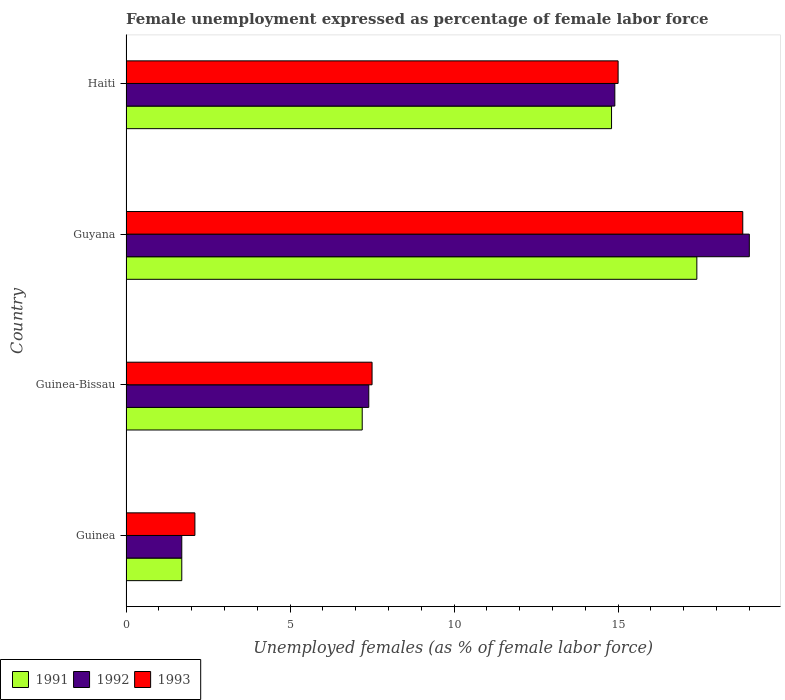How many groups of bars are there?
Offer a very short reply. 4. Are the number of bars per tick equal to the number of legend labels?
Your answer should be compact. Yes. What is the label of the 4th group of bars from the top?
Keep it short and to the point. Guinea. In how many cases, is the number of bars for a given country not equal to the number of legend labels?
Offer a very short reply. 0. What is the unemployment in females in in 1991 in Haiti?
Make the answer very short. 14.8. Across all countries, what is the maximum unemployment in females in in 1993?
Your response must be concise. 18.8. Across all countries, what is the minimum unemployment in females in in 1991?
Keep it short and to the point. 1.7. In which country was the unemployment in females in in 1992 maximum?
Offer a very short reply. Guyana. In which country was the unemployment in females in in 1992 minimum?
Your answer should be compact. Guinea. What is the total unemployment in females in in 1991 in the graph?
Your answer should be very brief. 41.1. What is the difference between the unemployment in females in in 1991 in Guinea and that in Guinea-Bissau?
Offer a very short reply. -5.5. What is the difference between the unemployment in females in in 1991 in Guinea-Bissau and the unemployment in females in in 1992 in Guinea?
Your response must be concise. 5.5. What is the average unemployment in females in in 1993 per country?
Offer a terse response. 10.85. What is the difference between the unemployment in females in in 1993 and unemployment in females in in 1992 in Guyana?
Offer a very short reply. -0.2. In how many countries, is the unemployment in females in in 1991 greater than 17 %?
Offer a very short reply. 1. What is the ratio of the unemployment in females in in 1991 in Guinea to that in Guinea-Bissau?
Provide a short and direct response. 0.24. Is the unemployment in females in in 1993 in Guinea less than that in Guinea-Bissau?
Make the answer very short. Yes. Is the difference between the unemployment in females in in 1993 in Guyana and Haiti greater than the difference between the unemployment in females in in 1992 in Guyana and Haiti?
Provide a succinct answer. No. What is the difference between the highest and the second highest unemployment in females in in 1991?
Your response must be concise. 2.6. What is the difference between the highest and the lowest unemployment in females in in 1991?
Keep it short and to the point. 15.7. In how many countries, is the unemployment in females in in 1991 greater than the average unemployment in females in in 1991 taken over all countries?
Give a very brief answer. 2. Is the sum of the unemployment in females in in 1992 in Guyana and Haiti greater than the maximum unemployment in females in in 1993 across all countries?
Give a very brief answer. Yes. What does the 2nd bar from the top in Guyana represents?
Ensure brevity in your answer.  1992. Is it the case that in every country, the sum of the unemployment in females in in 1991 and unemployment in females in in 1993 is greater than the unemployment in females in in 1992?
Offer a terse response. Yes. How many bars are there?
Make the answer very short. 12. How many countries are there in the graph?
Keep it short and to the point. 4. What is the difference between two consecutive major ticks on the X-axis?
Keep it short and to the point. 5. Are the values on the major ticks of X-axis written in scientific E-notation?
Keep it short and to the point. No. Does the graph contain any zero values?
Your answer should be very brief. No. Where does the legend appear in the graph?
Your response must be concise. Bottom left. What is the title of the graph?
Make the answer very short. Female unemployment expressed as percentage of female labor force. Does "2007" appear as one of the legend labels in the graph?
Give a very brief answer. No. What is the label or title of the X-axis?
Provide a short and direct response. Unemployed females (as % of female labor force). What is the label or title of the Y-axis?
Provide a succinct answer. Country. What is the Unemployed females (as % of female labor force) of 1991 in Guinea?
Make the answer very short. 1.7. What is the Unemployed females (as % of female labor force) of 1992 in Guinea?
Your answer should be very brief. 1.7. What is the Unemployed females (as % of female labor force) in 1993 in Guinea?
Offer a terse response. 2.1. What is the Unemployed females (as % of female labor force) of 1991 in Guinea-Bissau?
Your answer should be very brief. 7.2. What is the Unemployed females (as % of female labor force) in 1992 in Guinea-Bissau?
Make the answer very short. 7.4. What is the Unemployed females (as % of female labor force) of 1991 in Guyana?
Offer a terse response. 17.4. What is the Unemployed females (as % of female labor force) of 1993 in Guyana?
Provide a short and direct response. 18.8. What is the Unemployed females (as % of female labor force) of 1991 in Haiti?
Your answer should be very brief. 14.8. What is the Unemployed females (as % of female labor force) in 1992 in Haiti?
Provide a short and direct response. 14.9. Across all countries, what is the maximum Unemployed females (as % of female labor force) of 1991?
Make the answer very short. 17.4. Across all countries, what is the maximum Unemployed females (as % of female labor force) of 1993?
Ensure brevity in your answer.  18.8. Across all countries, what is the minimum Unemployed females (as % of female labor force) in 1991?
Give a very brief answer. 1.7. Across all countries, what is the minimum Unemployed females (as % of female labor force) of 1992?
Ensure brevity in your answer.  1.7. Across all countries, what is the minimum Unemployed females (as % of female labor force) of 1993?
Your answer should be compact. 2.1. What is the total Unemployed females (as % of female labor force) in 1991 in the graph?
Provide a short and direct response. 41.1. What is the total Unemployed females (as % of female labor force) in 1992 in the graph?
Keep it short and to the point. 43. What is the total Unemployed females (as % of female labor force) in 1993 in the graph?
Make the answer very short. 43.4. What is the difference between the Unemployed females (as % of female labor force) of 1991 in Guinea and that in Guyana?
Keep it short and to the point. -15.7. What is the difference between the Unemployed females (as % of female labor force) of 1992 in Guinea and that in Guyana?
Provide a succinct answer. -17.3. What is the difference between the Unemployed females (as % of female labor force) in 1993 in Guinea and that in Guyana?
Offer a terse response. -16.7. What is the difference between the Unemployed females (as % of female labor force) of 1992 in Guinea and that in Haiti?
Give a very brief answer. -13.2. What is the difference between the Unemployed females (as % of female labor force) in 1991 in Guinea-Bissau and that in Haiti?
Provide a short and direct response. -7.6. What is the difference between the Unemployed females (as % of female labor force) in 1992 in Guinea and the Unemployed females (as % of female labor force) in 1993 in Guinea-Bissau?
Offer a terse response. -5.8. What is the difference between the Unemployed females (as % of female labor force) of 1991 in Guinea and the Unemployed females (as % of female labor force) of 1992 in Guyana?
Make the answer very short. -17.3. What is the difference between the Unemployed females (as % of female labor force) in 1991 in Guinea and the Unemployed females (as % of female labor force) in 1993 in Guyana?
Make the answer very short. -17.1. What is the difference between the Unemployed females (as % of female labor force) in 1992 in Guinea and the Unemployed females (as % of female labor force) in 1993 in Guyana?
Ensure brevity in your answer.  -17.1. What is the difference between the Unemployed females (as % of female labor force) in 1991 in Guinea and the Unemployed females (as % of female labor force) in 1993 in Haiti?
Keep it short and to the point. -13.3. What is the difference between the Unemployed females (as % of female labor force) in 1992 in Guinea and the Unemployed females (as % of female labor force) in 1993 in Haiti?
Your answer should be very brief. -13.3. What is the difference between the Unemployed females (as % of female labor force) of 1991 in Guinea-Bissau and the Unemployed females (as % of female labor force) of 1993 in Guyana?
Provide a short and direct response. -11.6. What is the difference between the Unemployed females (as % of female labor force) in 1991 in Guinea-Bissau and the Unemployed females (as % of female labor force) in 1993 in Haiti?
Your response must be concise. -7.8. What is the difference between the Unemployed females (as % of female labor force) of 1992 in Guinea-Bissau and the Unemployed females (as % of female labor force) of 1993 in Haiti?
Give a very brief answer. -7.6. What is the difference between the Unemployed females (as % of female labor force) in 1992 in Guyana and the Unemployed females (as % of female labor force) in 1993 in Haiti?
Provide a short and direct response. 4. What is the average Unemployed females (as % of female labor force) in 1991 per country?
Your answer should be very brief. 10.28. What is the average Unemployed females (as % of female labor force) of 1992 per country?
Your answer should be very brief. 10.75. What is the average Unemployed females (as % of female labor force) of 1993 per country?
Provide a succinct answer. 10.85. What is the difference between the Unemployed females (as % of female labor force) in 1991 and Unemployed females (as % of female labor force) in 1992 in Guinea-Bissau?
Offer a terse response. -0.2. What is the difference between the Unemployed females (as % of female labor force) in 1992 and Unemployed females (as % of female labor force) in 1993 in Guinea-Bissau?
Ensure brevity in your answer.  -0.1. What is the difference between the Unemployed females (as % of female labor force) of 1991 and Unemployed females (as % of female labor force) of 1992 in Guyana?
Your response must be concise. -1.6. What is the difference between the Unemployed females (as % of female labor force) in 1991 and Unemployed females (as % of female labor force) in 1993 in Guyana?
Make the answer very short. -1.4. What is the difference between the Unemployed females (as % of female labor force) of 1992 and Unemployed females (as % of female labor force) of 1993 in Guyana?
Make the answer very short. 0.2. What is the difference between the Unemployed females (as % of female labor force) of 1991 and Unemployed females (as % of female labor force) of 1993 in Haiti?
Give a very brief answer. -0.2. What is the ratio of the Unemployed females (as % of female labor force) of 1991 in Guinea to that in Guinea-Bissau?
Your answer should be very brief. 0.24. What is the ratio of the Unemployed females (as % of female labor force) in 1992 in Guinea to that in Guinea-Bissau?
Your response must be concise. 0.23. What is the ratio of the Unemployed females (as % of female labor force) of 1993 in Guinea to that in Guinea-Bissau?
Provide a short and direct response. 0.28. What is the ratio of the Unemployed females (as % of female labor force) of 1991 in Guinea to that in Guyana?
Your response must be concise. 0.1. What is the ratio of the Unemployed females (as % of female labor force) of 1992 in Guinea to that in Guyana?
Keep it short and to the point. 0.09. What is the ratio of the Unemployed females (as % of female labor force) in 1993 in Guinea to that in Guyana?
Ensure brevity in your answer.  0.11. What is the ratio of the Unemployed females (as % of female labor force) in 1991 in Guinea to that in Haiti?
Make the answer very short. 0.11. What is the ratio of the Unemployed females (as % of female labor force) in 1992 in Guinea to that in Haiti?
Your answer should be compact. 0.11. What is the ratio of the Unemployed females (as % of female labor force) of 1993 in Guinea to that in Haiti?
Offer a terse response. 0.14. What is the ratio of the Unemployed females (as % of female labor force) of 1991 in Guinea-Bissau to that in Guyana?
Your answer should be very brief. 0.41. What is the ratio of the Unemployed females (as % of female labor force) in 1992 in Guinea-Bissau to that in Guyana?
Make the answer very short. 0.39. What is the ratio of the Unemployed females (as % of female labor force) in 1993 in Guinea-Bissau to that in Guyana?
Make the answer very short. 0.4. What is the ratio of the Unemployed females (as % of female labor force) of 1991 in Guinea-Bissau to that in Haiti?
Make the answer very short. 0.49. What is the ratio of the Unemployed females (as % of female labor force) in 1992 in Guinea-Bissau to that in Haiti?
Keep it short and to the point. 0.5. What is the ratio of the Unemployed females (as % of female labor force) of 1993 in Guinea-Bissau to that in Haiti?
Provide a short and direct response. 0.5. What is the ratio of the Unemployed females (as % of female labor force) in 1991 in Guyana to that in Haiti?
Your answer should be compact. 1.18. What is the ratio of the Unemployed females (as % of female labor force) in 1992 in Guyana to that in Haiti?
Keep it short and to the point. 1.28. What is the ratio of the Unemployed females (as % of female labor force) in 1993 in Guyana to that in Haiti?
Ensure brevity in your answer.  1.25. What is the difference between the highest and the second highest Unemployed females (as % of female labor force) in 1992?
Offer a very short reply. 4.1. What is the difference between the highest and the second highest Unemployed females (as % of female labor force) of 1993?
Ensure brevity in your answer.  3.8. What is the difference between the highest and the lowest Unemployed females (as % of female labor force) in 1992?
Provide a succinct answer. 17.3. 